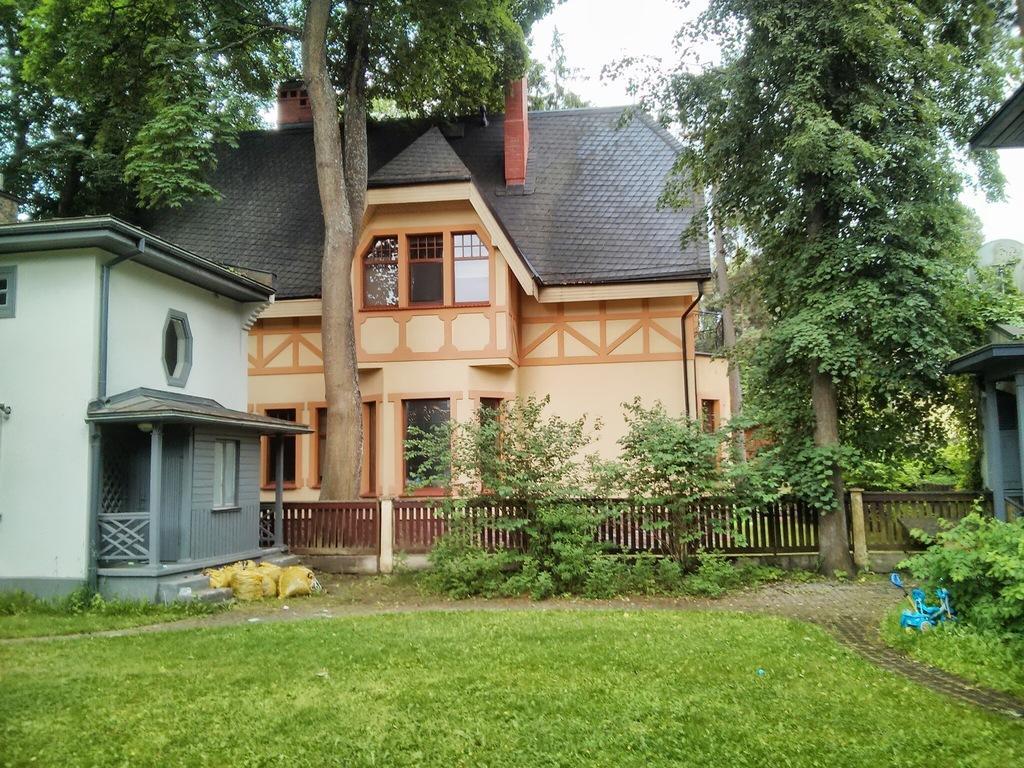Can you describe this image briefly? This image is taken outdoors. At the bottom of the image there is a ground with grass on it. In the middle of the image there are a few houses with walls, windows, roofs and doors. There is a railing and a fencing. In the background there are a few trees and plants. 